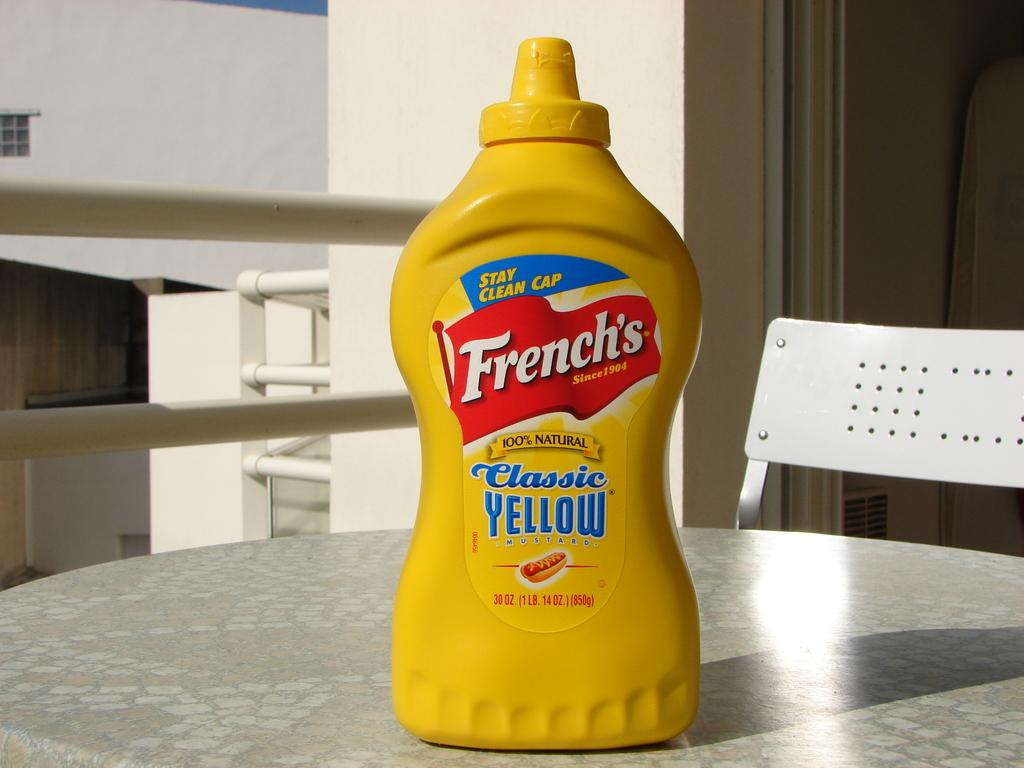<image>
Relay a brief, clear account of the picture shown. A bottle of French's mustard is on a table. 